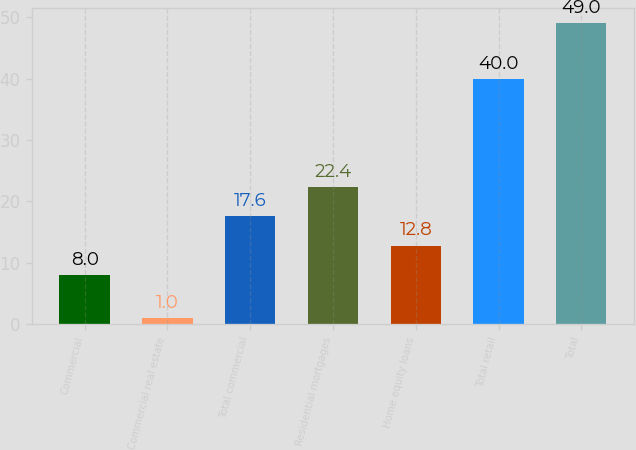Convert chart. <chart><loc_0><loc_0><loc_500><loc_500><bar_chart><fcel>Commercial<fcel>Commercial real estate<fcel>Total commercial<fcel>Residential mortgages<fcel>Home equity loans<fcel>Total retail<fcel>Total<nl><fcel>8<fcel>1<fcel>17.6<fcel>22.4<fcel>12.8<fcel>40<fcel>49<nl></chart> 